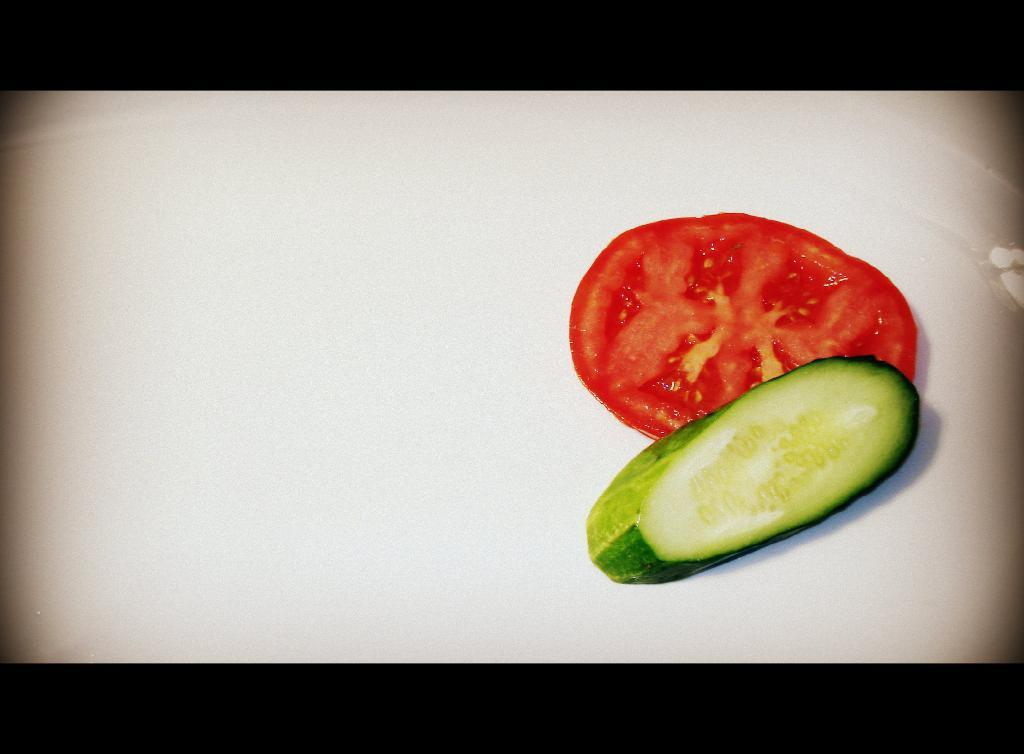What is the main subject of the image? The main subject of the image is vegetable slices. Where are the vegetable slices located in the image? The vegetable slices are in the center of the image. What type of grain is sprouting from the vegetable slices in the image? There is no grain present in the image; it only features vegetable slices. 